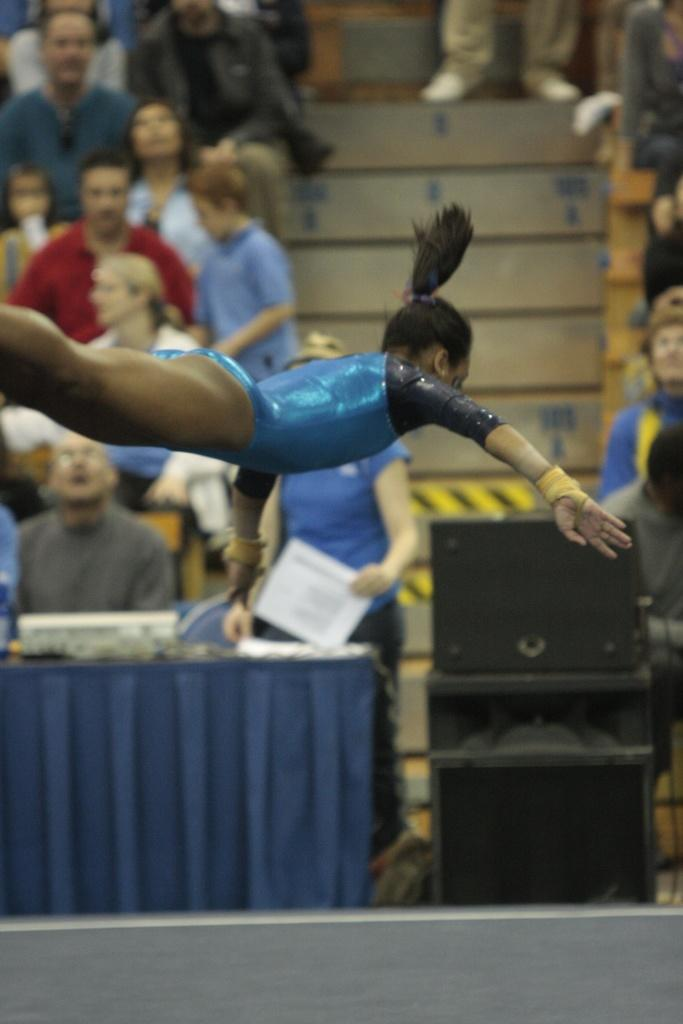What is the main subject of the image? There is a woman in the air in the image. What can be seen in the background of the image? There are people sitting in the background of the image. What architectural feature is visible in the image? There are steps visible in the image. What else is present on the ground in the image? There are other objects on the ground in the image. What type of loaf is being prepared for dinner in the image? There is no loaf or dinner preparation present in the image. What type of work is the woman in the air performing in the image? The image does not provide information about the woman's work or occupation. 